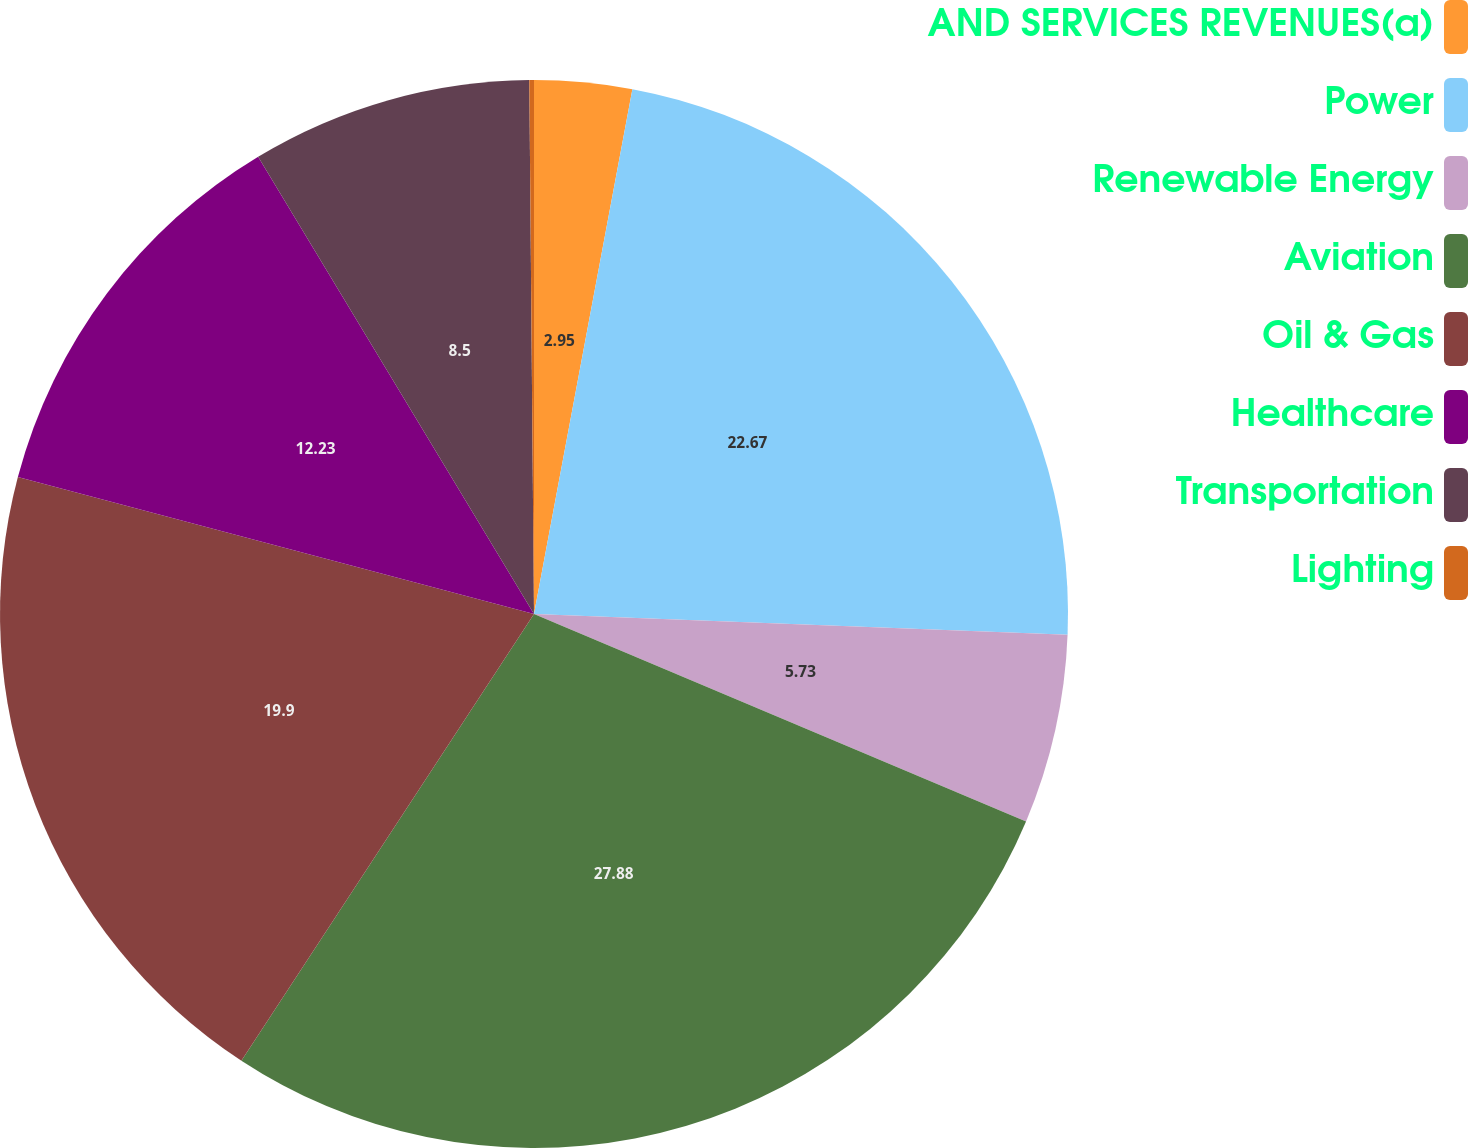<chart> <loc_0><loc_0><loc_500><loc_500><pie_chart><fcel>AND SERVICES REVENUES(a)<fcel>Power<fcel>Renewable Energy<fcel>Aviation<fcel>Oil & Gas<fcel>Healthcare<fcel>Transportation<fcel>Lighting<nl><fcel>2.95%<fcel>22.67%<fcel>5.73%<fcel>27.88%<fcel>19.9%<fcel>12.23%<fcel>8.5%<fcel>0.14%<nl></chart> 